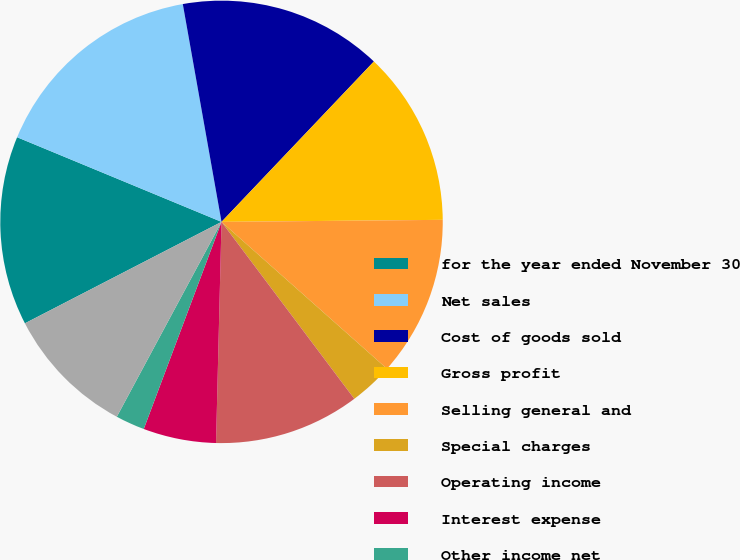Convert chart. <chart><loc_0><loc_0><loc_500><loc_500><pie_chart><fcel>for the year ended November 30<fcel>Net sales<fcel>Cost of goods sold<fcel>Gross profit<fcel>Selling general and<fcel>Special charges<fcel>Operating income<fcel>Interest expense<fcel>Other income net<fcel>Income from consolidated<nl><fcel>13.83%<fcel>15.95%<fcel>14.89%<fcel>12.76%<fcel>11.7%<fcel>3.2%<fcel>10.64%<fcel>5.32%<fcel>2.13%<fcel>9.57%<nl></chart> 